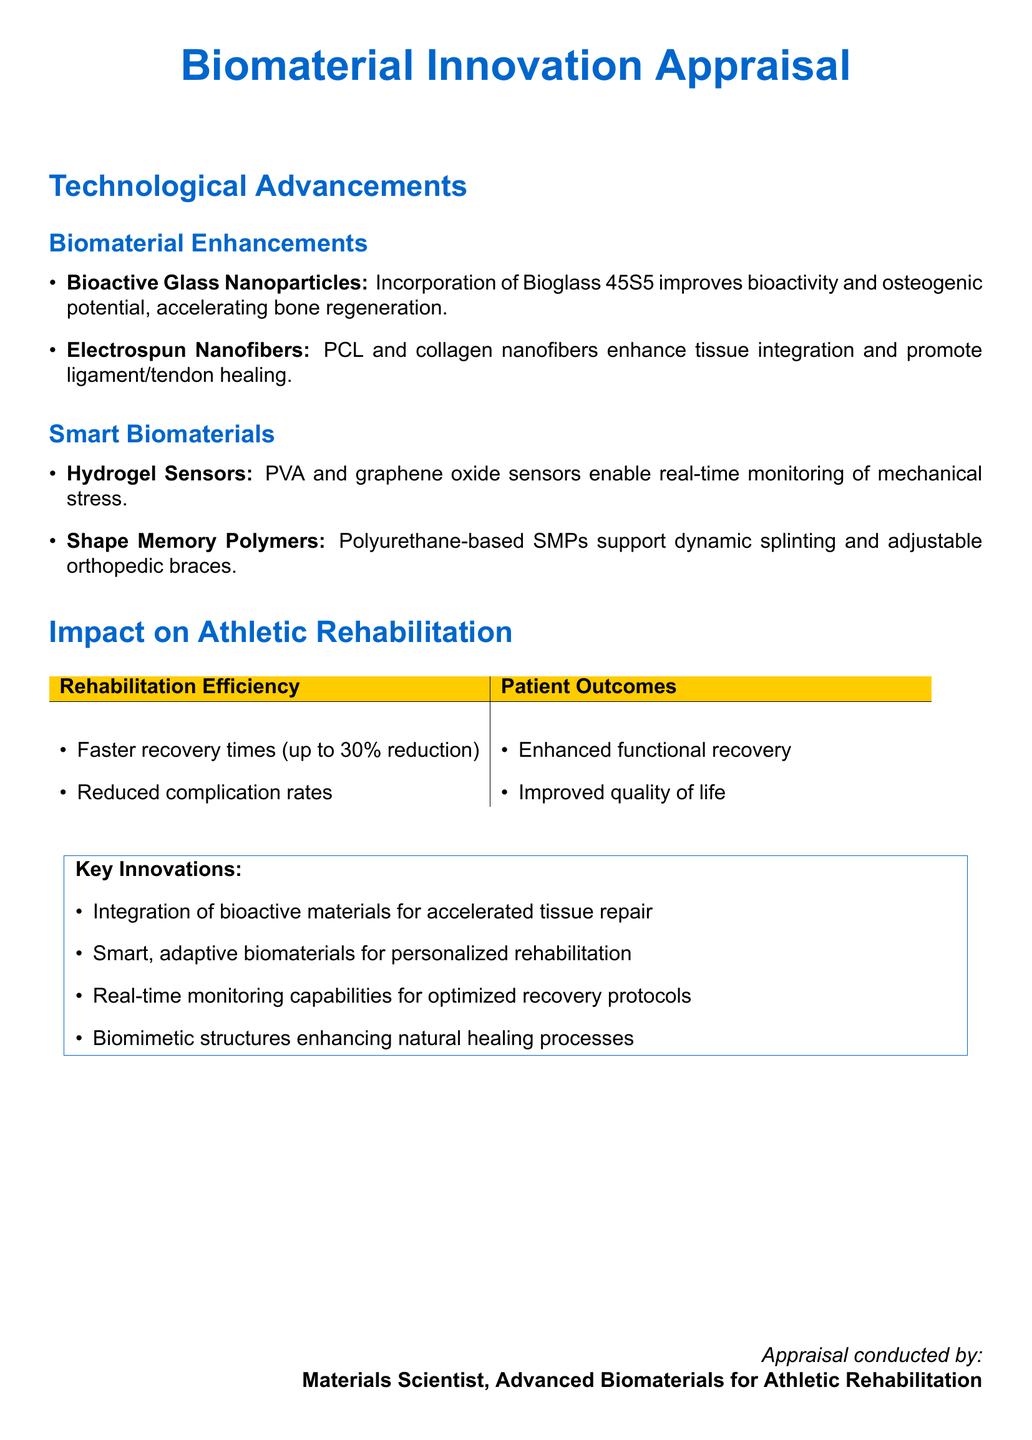What are the two main types of biomaterial enhancements mentioned? The document lists Bioactive Glass Nanoparticles and Electrospun Nanofibers as the two main types of biomaterial enhancements.
Answer: Bioactive Glass Nanoparticles, Electrospun Nanofibers How much faster are recovery times with the new biomaterials? The document states that recovery times can be reduced by up to 30 percent.
Answer: 30 percent What technology is used for real-time monitoring according to the document? The document specifies that PVA and graphene oxide sensors are used for real-time monitoring.
Answer: Hydrogel Sensors What is one key innovation in the biomaterials for rehabilitation? The document highlights the integration of bioactive materials for accelerating tissue repair as a key innovation.
Answer: Integration of bioactive materials What type of smart biomaterial supports dynamic splinting? According to the document, Polyurethane-based Shape Memory Polymers support dynamic splinting.
Answer: Shape Memory Polymers What is the impact on patient outcomes listed in the document? The document states that patient outcomes include enhanced functional recovery and improved quality of life.
Answer: Enhanced functional recovery, improved quality of life Which biomaterial is specifically mentioned for promoting ligament/tendon healing? The document mentions Electrospun Nanofibers for promoting ligament/tendon healing.
Answer: Electrospun Nanofibers What color scheme is used for the headings in the document? The document utilizes blue color for the headings, indicated by the RGB code.
Answer: Blue 